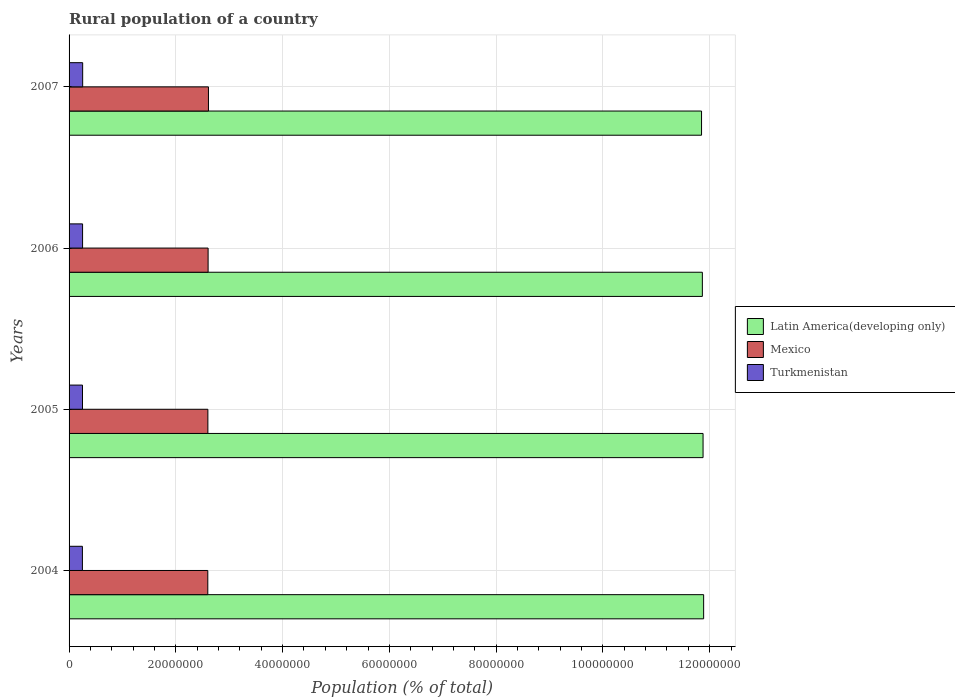How many groups of bars are there?
Give a very brief answer. 4. Are the number of bars on each tick of the Y-axis equal?
Give a very brief answer. Yes. How many bars are there on the 4th tick from the top?
Provide a short and direct response. 3. How many bars are there on the 1st tick from the bottom?
Give a very brief answer. 3. What is the label of the 1st group of bars from the top?
Your response must be concise. 2007. What is the rural population in Latin America(developing only) in 2007?
Ensure brevity in your answer.  1.18e+08. Across all years, what is the maximum rural population in Mexico?
Give a very brief answer. 2.61e+07. Across all years, what is the minimum rural population in Turkmenistan?
Offer a very short reply. 2.50e+06. In which year was the rural population in Latin America(developing only) maximum?
Your response must be concise. 2004. What is the total rural population in Turkmenistan in the graph?
Ensure brevity in your answer.  1.01e+07. What is the difference between the rural population in Mexico in 2004 and that in 2007?
Your response must be concise. -1.24e+05. What is the difference between the rural population in Mexico in 2005 and the rural population in Turkmenistan in 2007?
Ensure brevity in your answer.  2.35e+07. What is the average rural population in Latin America(developing only) per year?
Provide a succinct answer. 1.19e+08. In the year 2007, what is the difference between the rural population in Mexico and rural population in Latin America(developing only)?
Ensure brevity in your answer.  -9.24e+07. In how many years, is the rural population in Latin America(developing only) greater than 8000000 %?
Your answer should be very brief. 4. What is the ratio of the rural population in Latin America(developing only) in 2004 to that in 2005?
Provide a short and direct response. 1. Is the rural population in Latin America(developing only) in 2005 less than that in 2006?
Offer a terse response. No. What is the difference between the highest and the second highest rural population in Mexico?
Provide a short and direct response. 6.45e+04. What is the difference between the highest and the lowest rural population in Turkmenistan?
Offer a very short reply. 4.97e+04. What does the 3rd bar from the top in 2004 represents?
Provide a succinct answer. Latin America(developing only). What does the 2nd bar from the bottom in 2006 represents?
Provide a succinct answer. Mexico. Are all the bars in the graph horizontal?
Offer a terse response. Yes. How many years are there in the graph?
Provide a short and direct response. 4. What is the difference between two consecutive major ticks on the X-axis?
Ensure brevity in your answer.  2.00e+07. Where does the legend appear in the graph?
Provide a succinct answer. Center right. How are the legend labels stacked?
Provide a succinct answer. Vertical. What is the title of the graph?
Keep it short and to the point. Rural population of a country. Does "Brazil" appear as one of the legend labels in the graph?
Your response must be concise. No. What is the label or title of the X-axis?
Offer a very short reply. Population (% of total). What is the Population (% of total) of Latin America(developing only) in 2004?
Provide a succinct answer. 1.19e+08. What is the Population (% of total) of Mexico in 2004?
Give a very brief answer. 2.60e+07. What is the Population (% of total) in Turkmenistan in 2004?
Provide a succinct answer. 2.50e+06. What is the Population (% of total) of Latin America(developing only) in 2005?
Keep it short and to the point. 1.19e+08. What is the Population (% of total) of Mexico in 2005?
Make the answer very short. 2.60e+07. What is the Population (% of total) of Turkmenistan in 2005?
Ensure brevity in your answer.  2.51e+06. What is the Population (% of total) in Latin America(developing only) in 2006?
Ensure brevity in your answer.  1.19e+08. What is the Population (% of total) of Mexico in 2006?
Give a very brief answer. 2.60e+07. What is the Population (% of total) in Turkmenistan in 2006?
Make the answer very short. 2.53e+06. What is the Population (% of total) of Latin America(developing only) in 2007?
Provide a short and direct response. 1.18e+08. What is the Population (% of total) in Mexico in 2007?
Make the answer very short. 2.61e+07. What is the Population (% of total) in Turkmenistan in 2007?
Your answer should be compact. 2.55e+06. Across all years, what is the maximum Population (% of total) in Latin America(developing only)?
Your answer should be very brief. 1.19e+08. Across all years, what is the maximum Population (% of total) of Mexico?
Your answer should be compact. 2.61e+07. Across all years, what is the maximum Population (% of total) of Turkmenistan?
Make the answer very short. 2.55e+06. Across all years, what is the minimum Population (% of total) in Latin America(developing only)?
Provide a short and direct response. 1.18e+08. Across all years, what is the minimum Population (% of total) of Mexico?
Your answer should be compact. 2.60e+07. Across all years, what is the minimum Population (% of total) in Turkmenistan?
Offer a very short reply. 2.50e+06. What is the total Population (% of total) of Latin America(developing only) in the graph?
Offer a very short reply. 4.75e+08. What is the total Population (% of total) in Mexico in the graph?
Provide a succinct answer. 1.04e+08. What is the total Population (% of total) in Turkmenistan in the graph?
Your answer should be compact. 1.01e+07. What is the difference between the Population (% of total) of Latin America(developing only) in 2004 and that in 2005?
Ensure brevity in your answer.  1.09e+05. What is the difference between the Population (% of total) in Mexico in 2004 and that in 2005?
Your answer should be very brief. -1.63e+04. What is the difference between the Population (% of total) of Turkmenistan in 2004 and that in 2005?
Give a very brief answer. -1.59e+04. What is the difference between the Population (% of total) in Latin America(developing only) in 2004 and that in 2006?
Offer a very short reply. 2.39e+05. What is the difference between the Population (% of total) in Mexico in 2004 and that in 2006?
Provide a succinct answer. -5.95e+04. What is the difference between the Population (% of total) of Turkmenistan in 2004 and that in 2006?
Make the answer very short. -3.25e+04. What is the difference between the Population (% of total) in Latin America(developing only) in 2004 and that in 2007?
Offer a terse response. 3.92e+05. What is the difference between the Population (% of total) of Mexico in 2004 and that in 2007?
Keep it short and to the point. -1.24e+05. What is the difference between the Population (% of total) of Turkmenistan in 2004 and that in 2007?
Your response must be concise. -4.97e+04. What is the difference between the Population (% of total) in Latin America(developing only) in 2005 and that in 2006?
Offer a terse response. 1.31e+05. What is the difference between the Population (% of total) in Mexico in 2005 and that in 2006?
Provide a succinct answer. -4.32e+04. What is the difference between the Population (% of total) of Turkmenistan in 2005 and that in 2006?
Give a very brief answer. -1.66e+04. What is the difference between the Population (% of total) in Latin America(developing only) in 2005 and that in 2007?
Offer a very short reply. 2.83e+05. What is the difference between the Population (% of total) of Mexico in 2005 and that in 2007?
Keep it short and to the point. -1.08e+05. What is the difference between the Population (% of total) of Turkmenistan in 2005 and that in 2007?
Ensure brevity in your answer.  -3.38e+04. What is the difference between the Population (% of total) in Latin America(developing only) in 2006 and that in 2007?
Your answer should be compact. 1.52e+05. What is the difference between the Population (% of total) in Mexico in 2006 and that in 2007?
Keep it short and to the point. -6.45e+04. What is the difference between the Population (% of total) of Turkmenistan in 2006 and that in 2007?
Provide a succinct answer. -1.73e+04. What is the difference between the Population (% of total) in Latin America(developing only) in 2004 and the Population (% of total) in Mexico in 2005?
Make the answer very short. 9.29e+07. What is the difference between the Population (% of total) in Latin America(developing only) in 2004 and the Population (% of total) in Turkmenistan in 2005?
Keep it short and to the point. 1.16e+08. What is the difference between the Population (% of total) of Mexico in 2004 and the Population (% of total) of Turkmenistan in 2005?
Offer a very short reply. 2.35e+07. What is the difference between the Population (% of total) in Latin America(developing only) in 2004 and the Population (% of total) in Mexico in 2006?
Provide a short and direct response. 9.28e+07. What is the difference between the Population (% of total) of Latin America(developing only) in 2004 and the Population (% of total) of Turkmenistan in 2006?
Provide a succinct answer. 1.16e+08. What is the difference between the Population (% of total) in Mexico in 2004 and the Population (% of total) in Turkmenistan in 2006?
Your answer should be compact. 2.35e+07. What is the difference between the Population (% of total) of Latin America(developing only) in 2004 and the Population (% of total) of Mexico in 2007?
Keep it short and to the point. 9.28e+07. What is the difference between the Population (% of total) in Latin America(developing only) in 2004 and the Population (% of total) in Turkmenistan in 2007?
Give a very brief answer. 1.16e+08. What is the difference between the Population (% of total) of Mexico in 2004 and the Population (% of total) of Turkmenistan in 2007?
Keep it short and to the point. 2.34e+07. What is the difference between the Population (% of total) of Latin America(developing only) in 2005 and the Population (% of total) of Mexico in 2006?
Provide a succinct answer. 9.27e+07. What is the difference between the Population (% of total) in Latin America(developing only) in 2005 and the Population (% of total) in Turkmenistan in 2006?
Offer a very short reply. 1.16e+08. What is the difference between the Population (% of total) of Mexico in 2005 and the Population (% of total) of Turkmenistan in 2006?
Your response must be concise. 2.35e+07. What is the difference between the Population (% of total) of Latin America(developing only) in 2005 and the Population (% of total) of Mexico in 2007?
Offer a very short reply. 9.26e+07. What is the difference between the Population (% of total) in Latin America(developing only) in 2005 and the Population (% of total) in Turkmenistan in 2007?
Your response must be concise. 1.16e+08. What is the difference between the Population (% of total) of Mexico in 2005 and the Population (% of total) of Turkmenistan in 2007?
Provide a succinct answer. 2.35e+07. What is the difference between the Population (% of total) in Latin America(developing only) in 2006 and the Population (% of total) in Mexico in 2007?
Your answer should be compact. 9.25e+07. What is the difference between the Population (% of total) of Latin America(developing only) in 2006 and the Population (% of total) of Turkmenistan in 2007?
Ensure brevity in your answer.  1.16e+08. What is the difference between the Population (% of total) in Mexico in 2006 and the Population (% of total) in Turkmenistan in 2007?
Make the answer very short. 2.35e+07. What is the average Population (% of total) in Latin America(developing only) per year?
Your answer should be compact. 1.19e+08. What is the average Population (% of total) in Mexico per year?
Provide a short and direct response. 2.60e+07. What is the average Population (% of total) in Turkmenistan per year?
Offer a terse response. 2.52e+06. In the year 2004, what is the difference between the Population (% of total) of Latin America(developing only) and Population (% of total) of Mexico?
Your answer should be compact. 9.29e+07. In the year 2004, what is the difference between the Population (% of total) of Latin America(developing only) and Population (% of total) of Turkmenistan?
Keep it short and to the point. 1.16e+08. In the year 2004, what is the difference between the Population (% of total) of Mexico and Population (% of total) of Turkmenistan?
Your answer should be compact. 2.35e+07. In the year 2005, what is the difference between the Population (% of total) of Latin America(developing only) and Population (% of total) of Mexico?
Give a very brief answer. 9.28e+07. In the year 2005, what is the difference between the Population (% of total) of Latin America(developing only) and Population (% of total) of Turkmenistan?
Ensure brevity in your answer.  1.16e+08. In the year 2005, what is the difference between the Population (% of total) in Mexico and Population (% of total) in Turkmenistan?
Provide a short and direct response. 2.35e+07. In the year 2006, what is the difference between the Population (% of total) of Latin America(developing only) and Population (% of total) of Mexico?
Give a very brief answer. 9.26e+07. In the year 2006, what is the difference between the Population (% of total) in Latin America(developing only) and Population (% of total) in Turkmenistan?
Ensure brevity in your answer.  1.16e+08. In the year 2006, what is the difference between the Population (% of total) of Mexico and Population (% of total) of Turkmenistan?
Make the answer very short. 2.35e+07. In the year 2007, what is the difference between the Population (% of total) in Latin America(developing only) and Population (% of total) in Mexico?
Your answer should be very brief. 9.24e+07. In the year 2007, what is the difference between the Population (% of total) in Latin America(developing only) and Population (% of total) in Turkmenistan?
Offer a very short reply. 1.16e+08. In the year 2007, what is the difference between the Population (% of total) of Mexico and Population (% of total) of Turkmenistan?
Offer a very short reply. 2.36e+07. What is the ratio of the Population (% of total) in Mexico in 2004 to that in 2005?
Give a very brief answer. 1. What is the ratio of the Population (% of total) of Latin America(developing only) in 2004 to that in 2006?
Provide a succinct answer. 1. What is the ratio of the Population (% of total) in Mexico in 2004 to that in 2006?
Provide a short and direct response. 1. What is the ratio of the Population (% of total) of Turkmenistan in 2004 to that in 2006?
Your answer should be very brief. 0.99. What is the ratio of the Population (% of total) of Turkmenistan in 2004 to that in 2007?
Make the answer very short. 0.98. What is the ratio of the Population (% of total) in Latin America(developing only) in 2005 to that in 2006?
Offer a terse response. 1. What is the ratio of the Population (% of total) in Turkmenistan in 2005 to that in 2006?
Your response must be concise. 0.99. What is the ratio of the Population (% of total) in Latin America(developing only) in 2005 to that in 2007?
Your answer should be very brief. 1. What is the ratio of the Population (% of total) in Turkmenistan in 2005 to that in 2007?
Give a very brief answer. 0.99. What is the ratio of the Population (% of total) in Latin America(developing only) in 2006 to that in 2007?
Ensure brevity in your answer.  1. What is the ratio of the Population (% of total) of Mexico in 2006 to that in 2007?
Offer a very short reply. 1. What is the difference between the highest and the second highest Population (% of total) in Latin America(developing only)?
Your answer should be very brief. 1.09e+05. What is the difference between the highest and the second highest Population (% of total) of Mexico?
Offer a very short reply. 6.45e+04. What is the difference between the highest and the second highest Population (% of total) in Turkmenistan?
Make the answer very short. 1.73e+04. What is the difference between the highest and the lowest Population (% of total) of Latin America(developing only)?
Offer a terse response. 3.92e+05. What is the difference between the highest and the lowest Population (% of total) of Mexico?
Your answer should be compact. 1.24e+05. What is the difference between the highest and the lowest Population (% of total) of Turkmenistan?
Provide a short and direct response. 4.97e+04. 